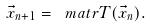Convert formula to latex. <formula><loc_0><loc_0><loc_500><loc_500>\vec { x } _ { n + 1 } = \ m a t r { T } ( \vec { x } _ { n } ) .</formula> 